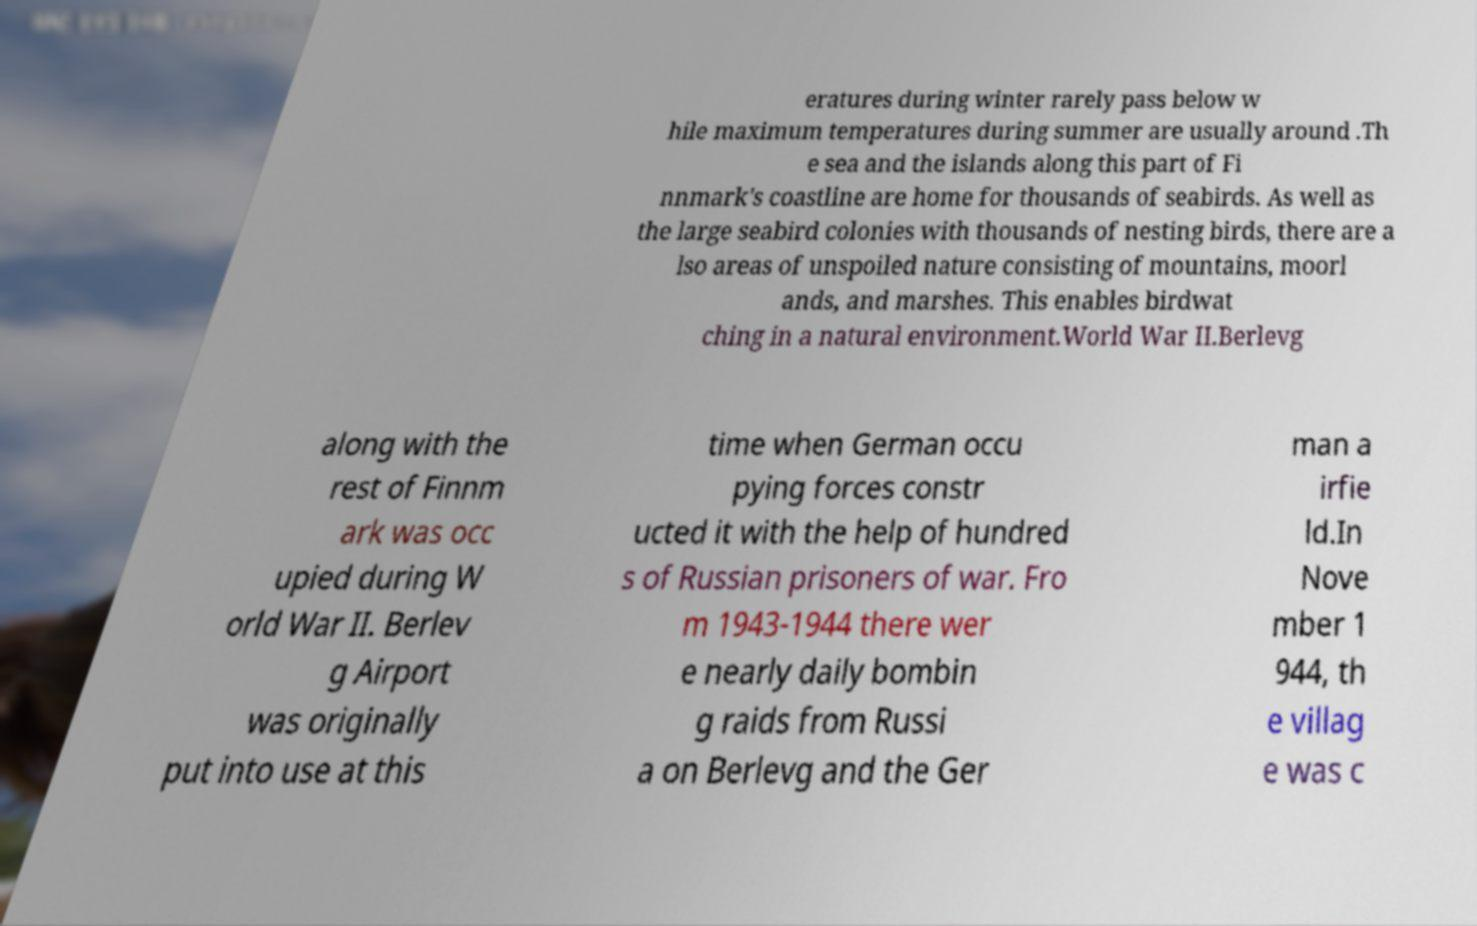For documentation purposes, I need the text within this image transcribed. Could you provide that? eratures during winter rarely pass below w hile maximum temperatures during summer are usually around .Th e sea and the islands along this part of Fi nnmark's coastline are home for thousands of seabirds. As well as the large seabird colonies with thousands of nesting birds, there are a lso areas of unspoiled nature consisting of mountains, moorl ands, and marshes. This enables birdwat ching in a natural environment.World War II.Berlevg along with the rest of Finnm ark was occ upied during W orld War II. Berlev g Airport was originally put into use at this time when German occu pying forces constr ucted it with the help of hundred s of Russian prisoners of war. Fro m 1943-1944 there wer e nearly daily bombin g raids from Russi a on Berlevg and the Ger man a irfie ld.In Nove mber 1 944, th e villag e was c 